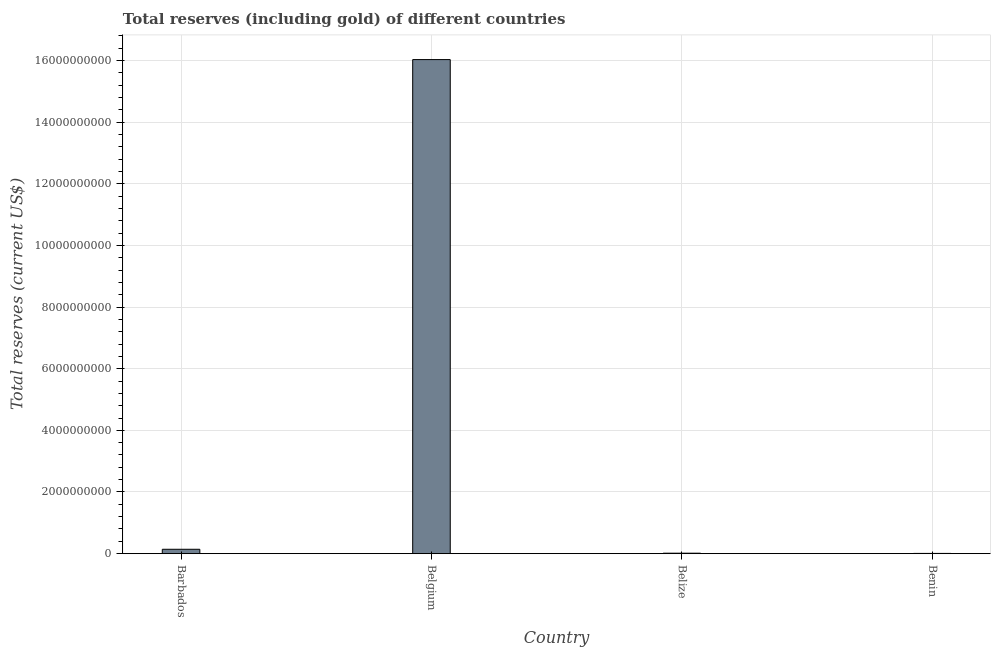Does the graph contain any zero values?
Offer a terse response. No. What is the title of the graph?
Offer a terse response. Total reserves (including gold) of different countries. What is the label or title of the Y-axis?
Provide a succinct answer. Total reserves (current US$). What is the total reserves (including gold) in Benin?
Your answer should be compact. 7.73e+06. Across all countries, what is the maximum total reserves (including gold)?
Give a very brief answer. 1.60e+1. Across all countries, what is the minimum total reserves (including gold)?
Your answer should be very brief. 7.73e+06. In which country was the total reserves (including gold) minimum?
Make the answer very short. Benin. What is the sum of the total reserves (including gold)?
Make the answer very short. 1.62e+1. What is the difference between the total reserves (including gold) in Barbados and Benin?
Keep it short and to the point. 1.34e+08. What is the average total reserves (including gold) per country?
Offer a terse response. 4.05e+09. What is the median total reserves (including gold)?
Give a very brief answer. 7.83e+07. In how many countries, is the total reserves (including gold) greater than 12400000000 US$?
Give a very brief answer. 1. What is the ratio of the total reserves (including gold) in Barbados to that in Belgium?
Offer a very short reply. 0.01. Is the difference between the total reserves (including gold) in Barbados and Belize greater than the difference between any two countries?
Keep it short and to the point. No. What is the difference between the highest and the second highest total reserves (including gold)?
Your answer should be very brief. 1.59e+1. Is the sum of the total reserves (including gold) in Belgium and Benin greater than the maximum total reserves (including gold) across all countries?
Your answer should be very brief. Yes. What is the difference between the highest and the lowest total reserves (including gold)?
Your answer should be compact. 1.60e+1. How many bars are there?
Your response must be concise. 4. Are all the bars in the graph horizontal?
Offer a terse response. No. How many countries are there in the graph?
Provide a succinct answer. 4. What is the difference between two consecutive major ticks on the Y-axis?
Make the answer very short. 2.00e+09. Are the values on the major ticks of Y-axis written in scientific E-notation?
Offer a very short reply. No. What is the Total reserves (current US$) of Barbados?
Provide a succinct answer. 1.42e+08. What is the Total reserves (current US$) of Belgium?
Keep it short and to the point. 1.60e+1. What is the Total reserves (current US$) of Belize?
Give a very brief answer. 1.48e+07. What is the Total reserves (current US$) of Benin?
Make the answer very short. 7.73e+06. What is the difference between the Total reserves (current US$) in Barbados and Belgium?
Your answer should be very brief. -1.59e+1. What is the difference between the Total reserves (current US$) in Barbados and Belize?
Keep it short and to the point. 1.27e+08. What is the difference between the Total reserves (current US$) in Barbados and Benin?
Make the answer very short. 1.34e+08. What is the difference between the Total reserves (current US$) in Belgium and Belize?
Make the answer very short. 1.60e+1. What is the difference between the Total reserves (current US$) in Belgium and Benin?
Give a very brief answer. 1.60e+1. What is the difference between the Total reserves (current US$) in Belize and Benin?
Provide a short and direct response. 7.08e+06. What is the ratio of the Total reserves (current US$) in Barbados to that in Belgium?
Give a very brief answer. 0.01. What is the ratio of the Total reserves (current US$) in Barbados to that in Belize?
Give a very brief answer. 9.57. What is the ratio of the Total reserves (current US$) in Barbados to that in Benin?
Provide a succinct answer. 18.33. What is the ratio of the Total reserves (current US$) in Belgium to that in Belize?
Your response must be concise. 1081.92. What is the ratio of the Total reserves (current US$) in Belgium to that in Benin?
Provide a short and direct response. 2072.68. What is the ratio of the Total reserves (current US$) in Belize to that in Benin?
Make the answer very short. 1.92. 